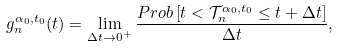<formula> <loc_0><loc_0><loc_500><loc_500>g _ { n } ^ { \alpha _ { 0 } , t _ { 0 } } ( t ) = \lim _ { \Delta t \rightarrow 0 ^ { + } } \frac { P r o b \left [ t < \mathcal { T } _ { n } ^ { \alpha _ { 0 } , t _ { 0 } } \leq t + \Delta t \right ] } { \Delta t } ,</formula> 